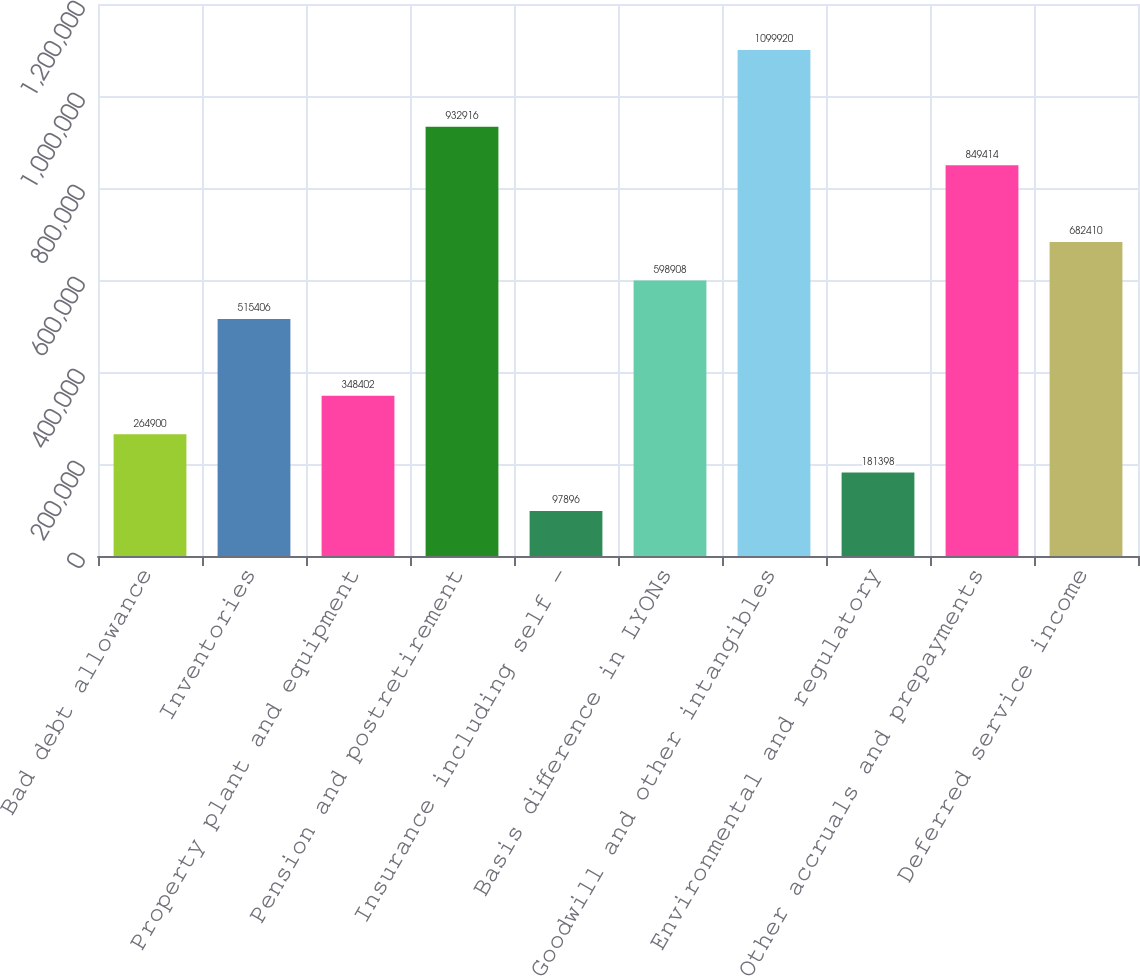Convert chart. <chart><loc_0><loc_0><loc_500><loc_500><bar_chart><fcel>Bad debt allowance<fcel>Inventories<fcel>Property plant and equipment<fcel>Pension and postretirement<fcel>Insurance including self -<fcel>Basis difference in LYONs<fcel>Goodwill and other intangibles<fcel>Environmental and regulatory<fcel>Other accruals and prepayments<fcel>Deferred service income<nl><fcel>264900<fcel>515406<fcel>348402<fcel>932916<fcel>97896<fcel>598908<fcel>1.09992e+06<fcel>181398<fcel>849414<fcel>682410<nl></chart> 